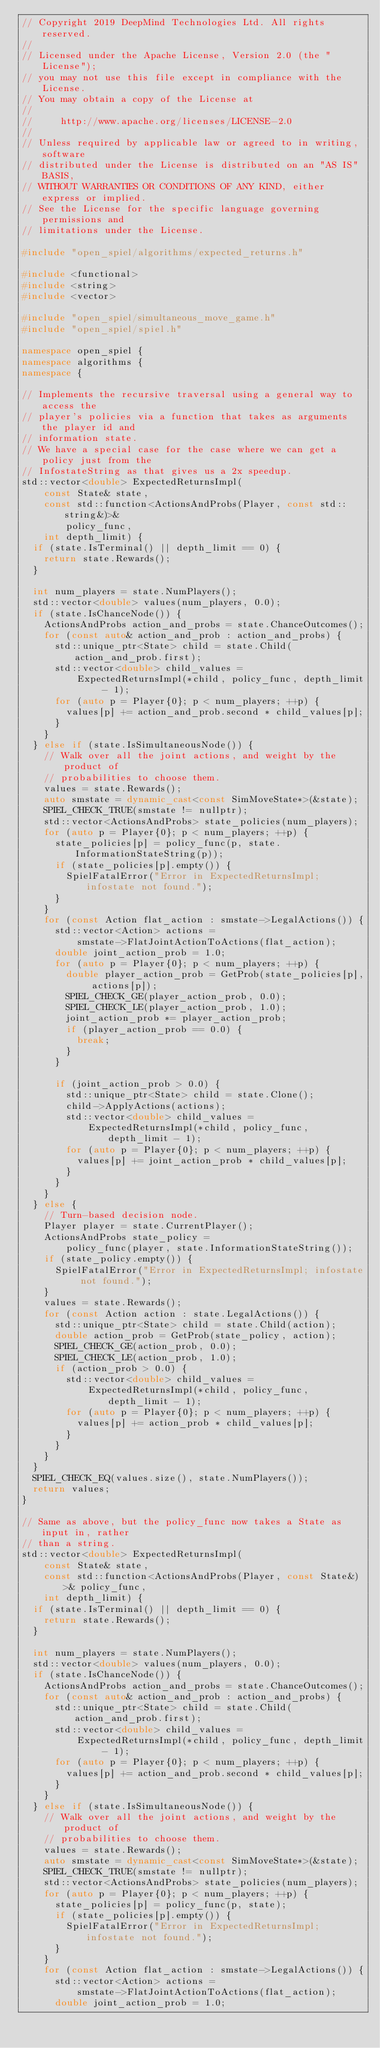<code> <loc_0><loc_0><loc_500><loc_500><_C++_>// Copyright 2019 DeepMind Technologies Ltd. All rights reserved.
//
// Licensed under the Apache License, Version 2.0 (the "License");
// you may not use this file except in compliance with the License.
// You may obtain a copy of the License at
//
//     http://www.apache.org/licenses/LICENSE-2.0
//
// Unless required by applicable law or agreed to in writing, software
// distributed under the License is distributed on an "AS IS" BASIS,
// WITHOUT WARRANTIES OR CONDITIONS OF ANY KIND, either express or implied.
// See the License for the specific language governing permissions and
// limitations under the License.

#include "open_spiel/algorithms/expected_returns.h"

#include <functional>
#include <string>
#include <vector>

#include "open_spiel/simultaneous_move_game.h"
#include "open_spiel/spiel.h"

namespace open_spiel {
namespace algorithms {
namespace {

// Implements the recursive traversal using a general way to access the
// player's policies via a function that takes as arguments the player id and
// information state.
// We have a special case for the case where we can get a policy just from the
// InfostateString as that gives us a 2x speedup.
std::vector<double> ExpectedReturnsImpl(
    const State& state,
    const std::function<ActionsAndProbs(Player, const std::string&)>&
        policy_func,
    int depth_limit) {
  if (state.IsTerminal() || depth_limit == 0) {
    return state.Rewards();
  }

  int num_players = state.NumPlayers();
  std::vector<double> values(num_players, 0.0);
  if (state.IsChanceNode()) {
    ActionsAndProbs action_and_probs = state.ChanceOutcomes();
    for (const auto& action_and_prob : action_and_probs) {
      std::unique_ptr<State> child = state.Child(action_and_prob.first);
      std::vector<double> child_values =
          ExpectedReturnsImpl(*child, policy_func, depth_limit - 1);
      for (auto p = Player{0}; p < num_players; ++p) {
        values[p] += action_and_prob.second * child_values[p];
      }
    }
  } else if (state.IsSimultaneousNode()) {
    // Walk over all the joint actions, and weight by the product of
    // probabilities to choose them.
    values = state.Rewards();
    auto smstate = dynamic_cast<const SimMoveState*>(&state);
    SPIEL_CHECK_TRUE(smstate != nullptr);
    std::vector<ActionsAndProbs> state_policies(num_players);
    for (auto p = Player{0}; p < num_players; ++p) {
      state_policies[p] = policy_func(p, state.InformationStateString(p));
      if (state_policies[p].empty()) {
        SpielFatalError("Error in ExpectedReturnsImpl; infostate not found.");
      }
    }
    for (const Action flat_action : smstate->LegalActions()) {
      std::vector<Action> actions =
          smstate->FlatJointActionToActions(flat_action);
      double joint_action_prob = 1.0;
      for (auto p = Player{0}; p < num_players; ++p) {
        double player_action_prob = GetProb(state_policies[p], actions[p]);
        SPIEL_CHECK_GE(player_action_prob, 0.0);
        SPIEL_CHECK_LE(player_action_prob, 1.0);
        joint_action_prob *= player_action_prob;
        if (player_action_prob == 0.0) {
          break;
        }
      }

      if (joint_action_prob > 0.0) {
        std::unique_ptr<State> child = state.Clone();
        child->ApplyActions(actions);
        std::vector<double> child_values =
            ExpectedReturnsImpl(*child, policy_func, depth_limit - 1);
        for (auto p = Player{0}; p < num_players; ++p) {
          values[p] += joint_action_prob * child_values[p];
        }
      }
    }
  } else {
    // Turn-based decision node.
    Player player = state.CurrentPlayer();
    ActionsAndProbs state_policy =
        policy_func(player, state.InformationStateString());
    if (state_policy.empty()) {
      SpielFatalError("Error in ExpectedReturnsImpl; infostate not found.");
    }
    values = state.Rewards();
    for (const Action action : state.LegalActions()) {
      std::unique_ptr<State> child = state.Child(action);
      double action_prob = GetProb(state_policy, action);
      SPIEL_CHECK_GE(action_prob, 0.0);
      SPIEL_CHECK_LE(action_prob, 1.0);
      if (action_prob > 0.0) {
        std::vector<double> child_values =
            ExpectedReturnsImpl(*child, policy_func, depth_limit - 1);
        for (auto p = Player{0}; p < num_players; ++p) {
          values[p] += action_prob * child_values[p];
        }
      }
    }
  }
  SPIEL_CHECK_EQ(values.size(), state.NumPlayers());
  return values;
}

// Same as above, but the policy_func now takes a State as input in, rather
// than a string.
std::vector<double> ExpectedReturnsImpl(
    const State& state,
    const std::function<ActionsAndProbs(Player, const State&)>& policy_func,
    int depth_limit) {
  if (state.IsTerminal() || depth_limit == 0) {
    return state.Rewards();
  }

  int num_players = state.NumPlayers();
  std::vector<double> values(num_players, 0.0);
  if (state.IsChanceNode()) {
    ActionsAndProbs action_and_probs = state.ChanceOutcomes();
    for (const auto& action_and_prob : action_and_probs) {
      std::unique_ptr<State> child = state.Child(action_and_prob.first);
      std::vector<double> child_values =
          ExpectedReturnsImpl(*child, policy_func, depth_limit - 1);
      for (auto p = Player{0}; p < num_players; ++p) {
        values[p] += action_and_prob.second * child_values[p];
      }
    }
  } else if (state.IsSimultaneousNode()) {
    // Walk over all the joint actions, and weight by the product of
    // probabilities to choose them.
    values = state.Rewards();
    auto smstate = dynamic_cast<const SimMoveState*>(&state);
    SPIEL_CHECK_TRUE(smstate != nullptr);
    std::vector<ActionsAndProbs> state_policies(num_players);
    for (auto p = Player{0}; p < num_players; ++p) {
      state_policies[p] = policy_func(p, state);
      if (state_policies[p].empty()) {
        SpielFatalError("Error in ExpectedReturnsImpl; infostate not found.");
      }
    }
    for (const Action flat_action : smstate->LegalActions()) {
      std::vector<Action> actions =
          smstate->FlatJointActionToActions(flat_action);
      double joint_action_prob = 1.0;</code> 